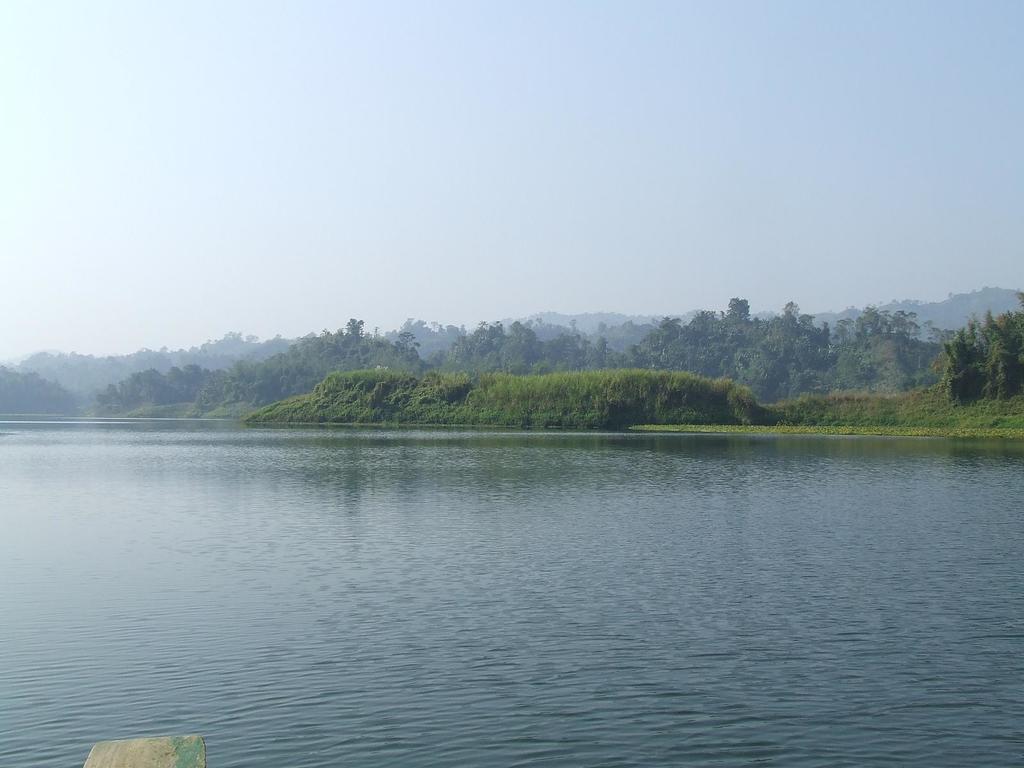Describe this image in one or two sentences. In this picture there is water at the bottom side of the image and there are trees in the center of the image. 